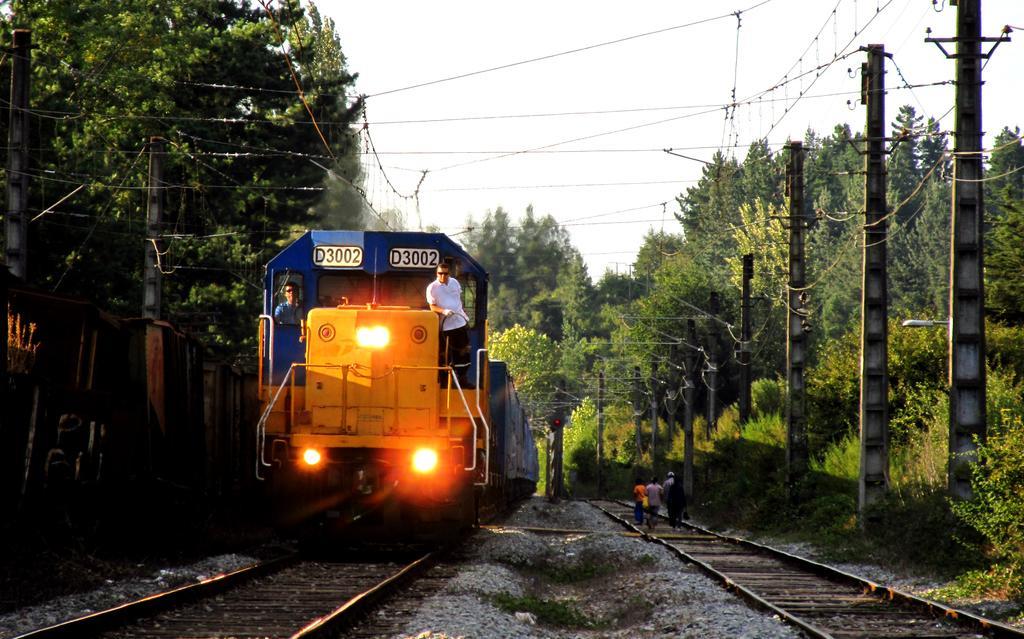Could you give a brief overview of what you see in this image? This image is clicked outside. There are trees in the middle. There is a train in the middle. There are railway tracks at the bottom. There is sky at the top. There are two persons standing in the train. 